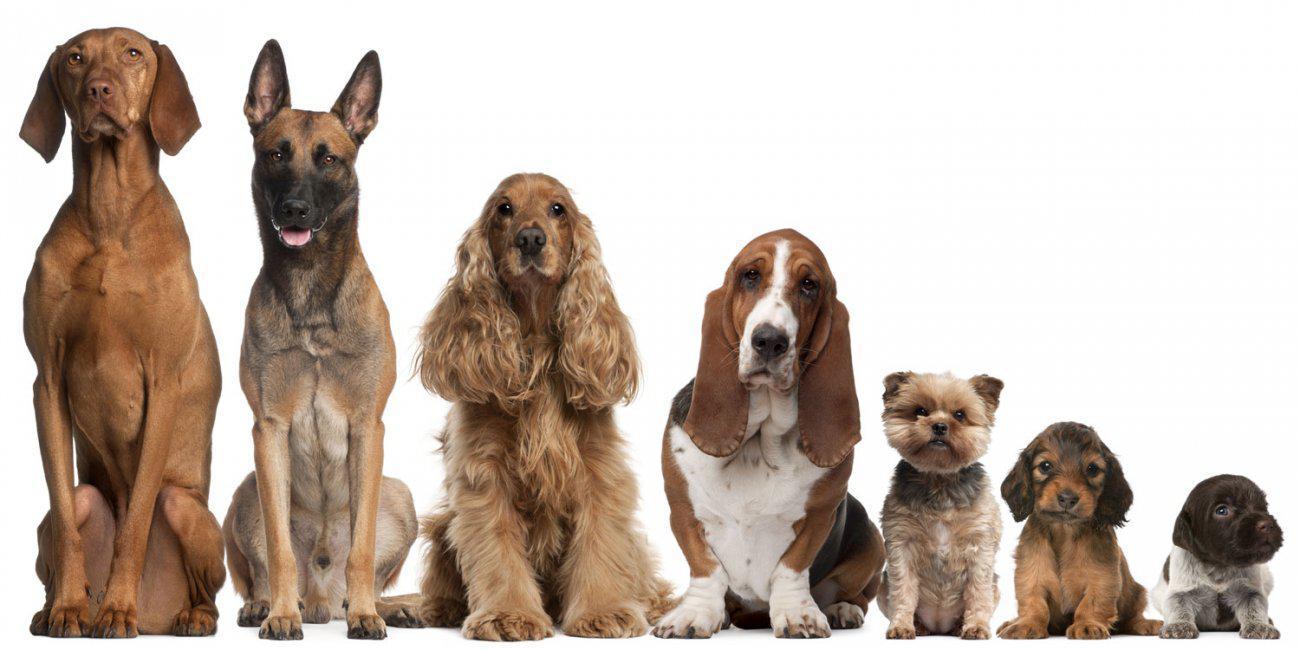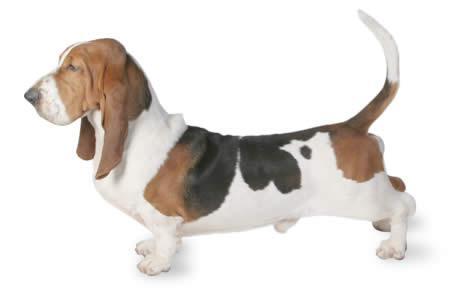The first image is the image on the left, the second image is the image on the right. For the images displayed, is the sentence "There are at least seven dogs." factually correct? Answer yes or no. Yes. 